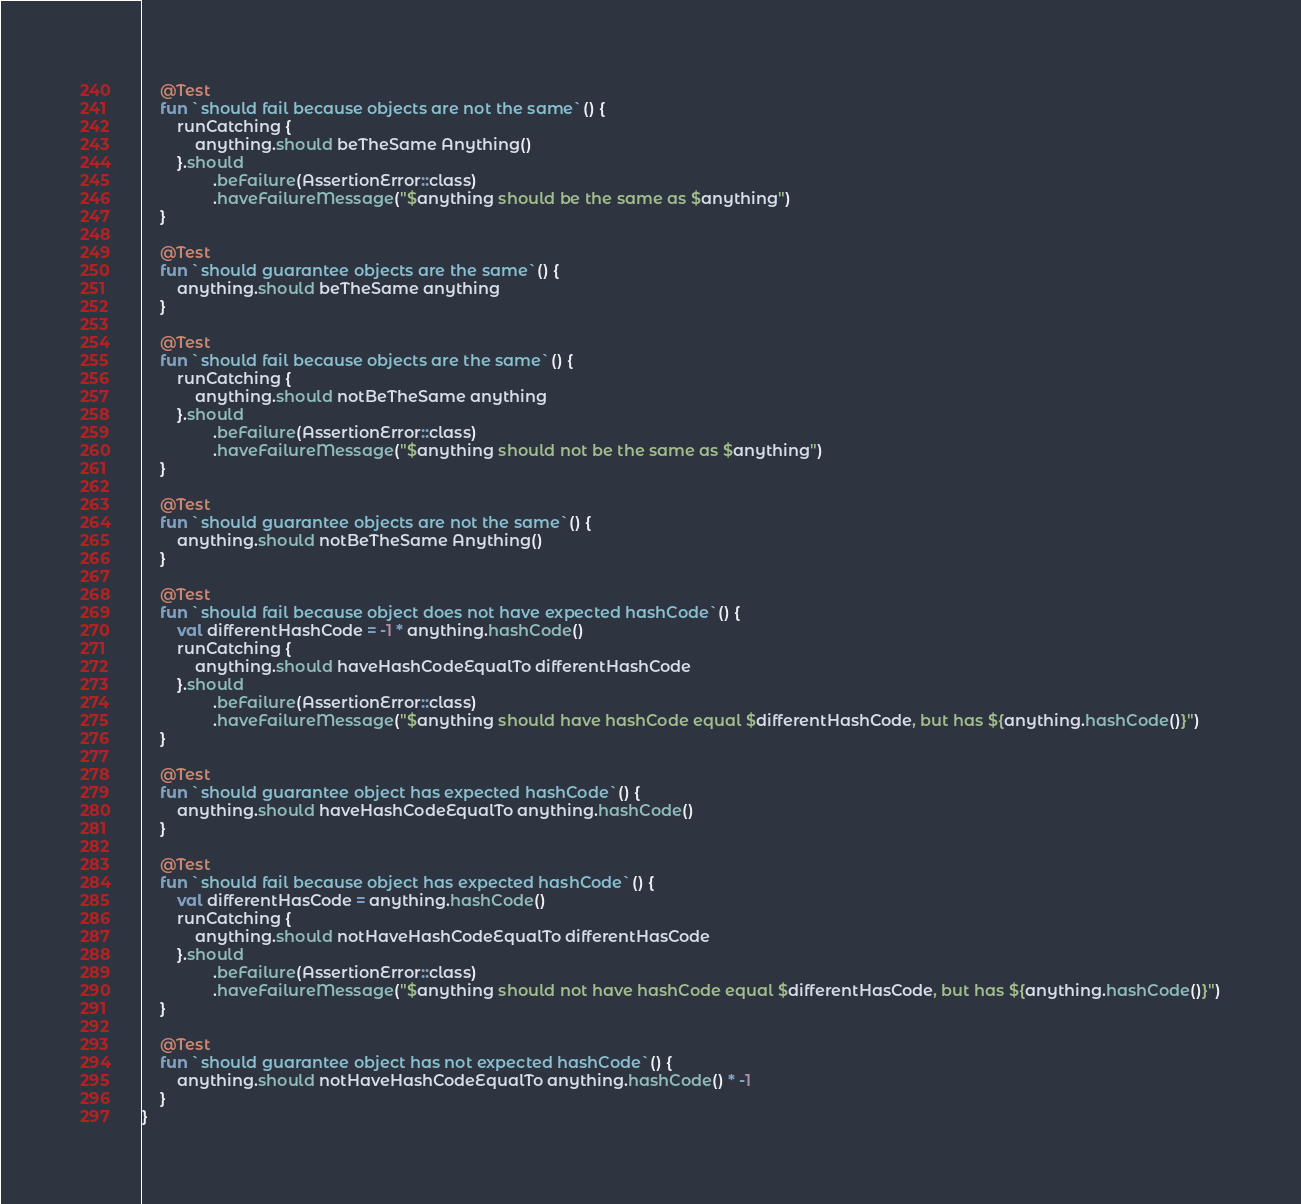Convert code to text. <code><loc_0><loc_0><loc_500><loc_500><_Kotlin_>    @Test
    fun `should fail because objects are not the same`() {
        runCatching {
            anything.should beTheSame Anything()
        }.should
                .beFailure(AssertionError::class)
                .haveFailureMessage("$anything should be the same as $anything")
    }

    @Test
    fun `should guarantee objects are the same`() {
        anything.should beTheSame anything
    }

    @Test
    fun `should fail because objects are the same`() {
        runCatching {
            anything.should notBeTheSame anything
        }.should
                .beFailure(AssertionError::class)
                .haveFailureMessage("$anything should not be the same as $anything")
    }

    @Test
    fun `should guarantee objects are not the same`() {
        anything.should notBeTheSame Anything()
    }

    @Test
    fun `should fail because object does not have expected hashCode`() {
        val differentHashCode = -1 * anything.hashCode()
        runCatching {
            anything.should haveHashCodeEqualTo differentHashCode
        }.should
                .beFailure(AssertionError::class)
                .haveFailureMessage("$anything should have hashCode equal $differentHashCode, but has ${anything.hashCode()}")
    }

    @Test
    fun `should guarantee object has expected hashCode`() {
        anything.should haveHashCodeEqualTo anything.hashCode()
    }

    @Test
    fun `should fail because object has expected hashCode`() {
        val differentHasCode = anything.hashCode()
        runCatching {
            anything.should notHaveHashCodeEqualTo differentHasCode
        }.should
                .beFailure(AssertionError::class)
                .haveFailureMessage("$anything should not have hashCode equal $differentHasCode, but has ${anything.hashCode()}")
    }

    @Test
    fun `should guarantee object has not expected hashCode`() {
        anything.should notHaveHashCodeEqualTo anything.hashCode() * -1
    }
}
</code> 